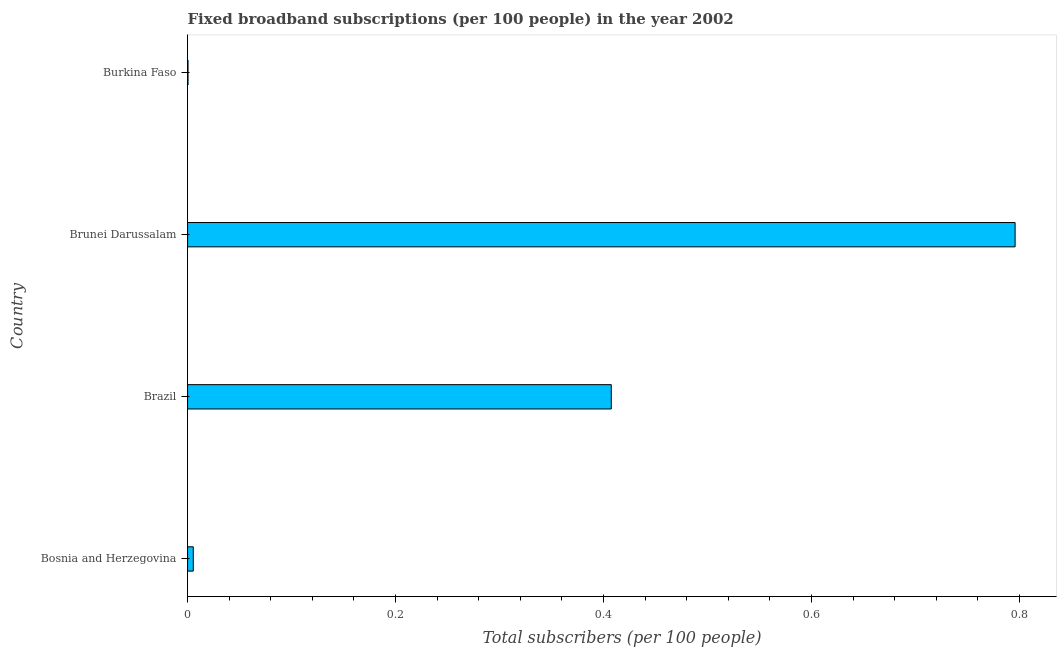What is the title of the graph?
Offer a terse response. Fixed broadband subscriptions (per 100 people) in the year 2002. What is the label or title of the X-axis?
Give a very brief answer. Total subscribers (per 100 people). What is the label or title of the Y-axis?
Ensure brevity in your answer.  Country. What is the total number of fixed broadband subscriptions in Bosnia and Herzegovina?
Your answer should be very brief. 0.01. Across all countries, what is the maximum total number of fixed broadband subscriptions?
Offer a terse response. 0.8. Across all countries, what is the minimum total number of fixed broadband subscriptions?
Provide a succinct answer. 0. In which country was the total number of fixed broadband subscriptions maximum?
Offer a terse response. Brunei Darussalam. In which country was the total number of fixed broadband subscriptions minimum?
Keep it short and to the point. Burkina Faso. What is the sum of the total number of fixed broadband subscriptions?
Give a very brief answer. 1.21. What is the difference between the total number of fixed broadband subscriptions in Brunei Darussalam and Burkina Faso?
Provide a short and direct response. 0.8. What is the average total number of fixed broadband subscriptions per country?
Offer a terse response. 0.3. What is the median total number of fixed broadband subscriptions?
Your answer should be compact. 0.21. In how many countries, is the total number of fixed broadband subscriptions greater than 0.12 ?
Provide a short and direct response. 2. What is the ratio of the total number of fixed broadband subscriptions in Brazil to that in Brunei Darussalam?
Your response must be concise. 0.51. Is the total number of fixed broadband subscriptions in Brazil less than that in Brunei Darussalam?
Give a very brief answer. Yes. Is the difference between the total number of fixed broadband subscriptions in Brunei Darussalam and Burkina Faso greater than the difference between any two countries?
Your response must be concise. Yes. What is the difference between the highest and the second highest total number of fixed broadband subscriptions?
Ensure brevity in your answer.  0.39. What is the difference between the highest and the lowest total number of fixed broadband subscriptions?
Your answer should be compact. 0.8. How many bars are there?
Keep it short and to the point. 4. How many countries are there in the graph?
Provide a short and direct response. 4. What is the difference between two consecutive major ticks on the X-axis?
Your answer should be compact. 0.2. Are the values on the major ticks of X-axis written in scientific E-notation?
Provide a succinct answer. No. What is the Total subscribers (per 100 people) in Bosnia and Herzegovina?
Give a very brief answer. 0.01. What is the Total subscribers (per 100 people) of Brazil?
Keep it short and to the point. 0.41. What is the Total subscribers (per 100 people) of Brunei Darussalam?
Your answer should be compact. 0.8. What is the Total subscribers (per 100 people) of Burkina Faso?
Your answer should be compact. 0. What is the difference between the Total subscribers (per 100 people) in Bosnia and Herzegovina and Brazil?
Offer a very short reply. -0.4. What is the difference between the Total subscribers (per 100 people) in Bosnia and Herzegovina and Brunei Darussalam?
Provide a short and direct response. -0.79. What is the difference between the Total subscribers (per 100 people) in Bosnia and Herzegovina and Burkina Faso?
Your answer should be very brief. 0.01. What is the difference between the Total subscribers (per 100 people) in Brazil and Brunei Darussalam?
Offer a very short reply. -0.39. What is the difference between the Total subscribers (per 100 people) in Brazil and Burkina Faso?
Your answer should be compact. 0.41. What is the difference between the Total subscribers (per 100 people) in Brunei Darussalam and Burkina Faso?
Ensure brevity in your answer.  0.8. What is the ratio of the Total subscribers (per 100 people) in Bosnia and Herzegovina to that in Brazil?
Provide a succinct answer. 0.01. What is the ratio of the Total subscribers (per 100 people) in Bosnia and Herzegovina to that in Brunei Darussalam?
Your response must be concise. 0.01. What is the ratio of the Total subscribers (per 100 people) in Bosnia and Herzegovina to that in Burkina Faso?
Ensure brevity in your answer.  13.44. What is the ratio of the Total subscribers (per 100 people) in Brazil to that in Brunei Darussalam?
Your answer should be compact. 0.51. What is the ratio of the Total subscribers (per 100 people) in Brazil to that in Burkina Faso?
Your answer should be compact. 1002.12. What is the ratio of the Total subscribers (per 100 people) in Brunei Darussalam to that in Burkina Faso?
Your response must be concise. 1957.3. 